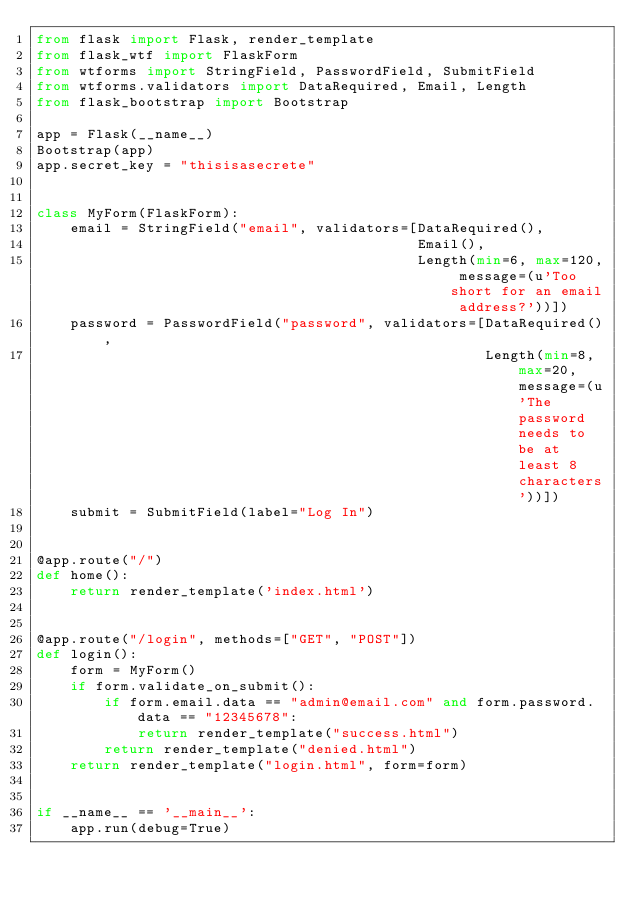Convert code to text. <code><loc_0><loc_0><loc_500><loc_500><_Python_>from flask import Flask, render_template
from flask_wtf import FlaskForm
from wtforms import StringField, PasswordField, SubmitField
from wtforms.validators import DataRequired, Email, Length
from flask_bootstrap import Bootstrap

app = Flask(__name__)
Bootstrap(app)
app.secret_key = "thisisasecrete"


class MyForm(FlaskForm):
    email = StringField("email", validators=[DataRequired(),
                                             Email(),
                                             Length(min=6, max=120, message=(u'Too short for an email address?'))])
    password = PasswordField("password", validators=[DataRequired(),
                                                     Length(min=8, max=20, message=(u'The password needs to be at least 8 characters'))])
    submit = SubmitField(label="Log In")


@app.route("/")
def home():
    return render_template('index.html')


@app.route("/login", methods=["GET", "POST"])
def login():
    form = MyForm()
    if form.validate_on_submit():
        if form.email.data == "admin@email.com" and form.password.data == "12345678":
            return render_template("success.html")
        return render_template("denied.html")
    return render_template("login.html", form=form)


if __name__ == '__main__':
    app.run(debug=True)
</code> 